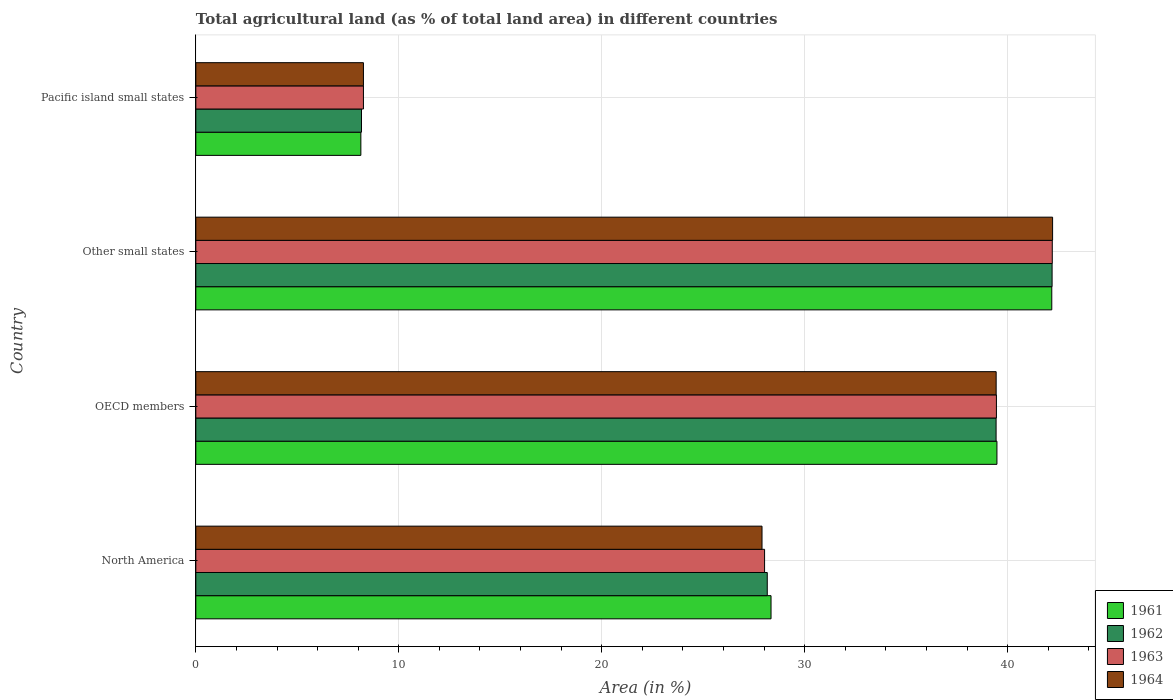Are the number of bars per tick equal to the number of legend labels?
Ensure brevity in your answer.  Yes. Are the number of bars on each tick of the Y-axis equal?
Give a very brief answer. Yes. How many bars are there on the 1st tick from the top?
Your answer should be compact. 4. How many bars are there on the 4th tick from the bottom?
Ensure brevity in your answer.  4. What is the percentage of agricultural land in 1961 in Other small states?
Provide a succinct answer. 42.18. Across all countries, what is the maximum percentage of agricultural land in 1962?
Keep it short and to the point. 42.19. Across all countries, what is the minimum percentage of agricultural land in 1961?
Your response must be concise. 8.13. In which country was the percentage of agricultural land in 1964 maximum?
Provide a short and direct response. Other small states. In which country was the percentage of agricultural land in 1961 minimum?
Ensure brevity in your answer.  Pacific island small states. What is the total percentage of agricultural land in 1963 in the graph?
Give a very brief answer. 117.93. What is the difference between the percentage of agricultural land in 1962 in OECD members and that in Pacific island small states?
Provide a short and direct response. 31.27. What is the difference between the percentage of agricultural land in 1962 in OECD members and the percentage of agricultural land in 1961 in Other small states?
Give a very brief answer. -2.74. What is the average percentage of agricultural land in 1962 per country?
Ensure brevity in your answer.  29.49. What is the difference between the percentage of agricultural land in 1962 and percentage of agricultural land in 1961 in OECD members?
Provide a succinct answer. -0.04. What is the ratio of the percentage of agricultural land in 1961 in North America to that in Pacific island small states?
Keep it short and to the point. 3.49. What is the difference between the highest and the second highest percentage of agricultural land in 1961?
Your answer should be compact. 2.7. What is the difference between the highest and the lowest percentage of agricultural land in 1961?
Give a very brief answer. 34.04. Is the sum of the percentage of agricultural land in 1963 in Other small states and Pacific island small states greater than the maximum percentage of agricultural land in 1962 across all countries?
Your answer should be compact. Yes. What does the 4th bar from the top in OECD members represents?
Provide a short and direct response. 1961. What does the 1st bar from the bottom in North America represents?
Offer a very short reply. 1961. Is it the case that in every country, the sum of the percentage of agricultural land in 1961 and percentage of agricultural land in 1962 is greater than the percentage of agricultural land in 1963?
Make the answer very short. Yes. Are all the bars in the graph horizontal?
Offer a very short reply. Yes. How many countries are there in the graph?
Your answer should be compact. 4. What is the difference between two consecutive major ticks on the X-axis?
Your answer should be compact. 10. Are the values on the major ticks of X-axis written in scientific E-notation?
Provide a succinct answer. No. Does the graph contain grids?
Provide a succinct answer. Yes. What is the title of the graph?
Make the answer very short. Total agricultural land (as % of total land area) in different countries. What is the label or title of the X-axis?
Offer a very short reply. Area (in %). What is the label or title of the Y-axis?
Offer a very short reply. Country. What is the Area (in %) in 1961 in North America?
Your answer should be compact. 28.34. What is the Area (in %) in 1962 in North America?
Offer a terse response. 28.16. What is the Area (in %) in 1963 in North America?
Ensure brevity in your answer.  28.02. What is the Area (in %) in 1964 in North America?
Your answer should be compact. 27.9. What is the Area (in %) of 1961 in OECD members?
Offer a very short reply. 39.47. What is the Area (in %) of 1962 in OECD members?
Your response must be concise. 39.43. What is the Area (in %) in 1963 in OECD members?
Your answer should be very brief. 39.45. What is the Area (in %) of 1964 in OECD members?
Offer a terse response. 39.44. What is the Area (in %) in 1961 in Other small states?
Make the answer very short. 42.18. What is the Area (in %) in 1962 in Other small states?
Provide a short and direct response. 42.19. What is the Area (in %) in 1963 in Other small states?
Provide a short and direct response. 42.2. What is the Area (in %) in 1964 in Other small states?
Your answer should be very brief. 42.22. What is the Area (in %) of 1961 in Pacific island small states?
Your response must be concise. 8.13. What is the Area (in %) of 1962 in Pacific island small states?
Your response must be concise. 8.16. What is the Area (in %) in 1963 in Pacific island small states?
Give a very brief answer. 8.26. What is the Area (in %) of 1964 in Pacific island small states?
Provide a short and direct response. 8.26. Across all countries, what is the maximum Area (in %) of 1961?
Your response must be concise. 42.18. Across all countries, what is the maximum Area (in %) of 1962?
Your answer should be very brief. 42.19. Across all countries, what is the maximum Area (in %) in 1963?
Offer a terse response. 42.2. Across all countries, what is the maximum Area (in %) in 1964?
Ensure brevity in your answer.  42.22. Across all countries, what is the minimum Area (in %) in 1961?
Provide a short and direct response. 8.13. Across all countries, what is the minimum Area (in %) in 1962?
Your answer should be compact. 8.16. Across all countries, what is the minimum Area (in %) in 1963?
Provide a succinct answer. 8.26. Across all countries, what is the minimum Area (in %) in 1964?
Provide a short and direct response. 8.26. What is the total Area (in %) of 1961 in the graph?
Offer a terse response. 118.13. What is the total Area (in %) in 1962 in the graph?
Make the answer very short. 117.95. What is the total Area (in %) of 1963 in the graph?
Make the answer very short. 117.93. What is the total Area (in %) in 1964 in the graph?
Give a very brief answer. 117.81. What is the difference between the Area (in %) in 1961 in North America and that in OECD members?
Keep it short and to the point. -11.13. What is the difference between the Area (in %) of 1962 in North America and that in OECD members?
Give a very brief answer. -11.28. What is the difference between the Area (in %) of 1963 in North America and that in OECD members?
Offer a terse response. -11.42. What is the difference between the Area (in %) in 1964 in North America and that in OECD members?
Your answer should be very brief. -11.54. What is the difference between the Area (in %) in 1961 in North America and that in Other small states?
Make the answer very short. -13.83. What is the difference between the Area (in %) of 1962 in North America and that in Other small states?
Provide a succinct answer. -14.03. What is the difference between the Area (in %) of 1963 in North America and that in Other small states?
Give a very brief answer. -14.18. What is the difference between the Area (in %) in 1964 in North America and that in Other small states?
Your answer should be compact. -14.32. What is the difference between the Area (in %) of 1961 in North America and that in Pacific island small states?
Your answer should be very brief. 20.21. What is the difference between the Area (in %) of 1962 in North America and that in Pacific island small states?
Give a very brief answer. 19.99. What is the difference between the Area (in %) of 1963 in North America and that in Pacific island small states?
Make the answer very short. 19.77. What is the difference between the Area (in %) of 1964 in North America and that in Pacific island small states?
Offer a very short reply. 19.64. What is the difference between the Area (in %) of 1961 in OECD members and that in Other small states?
Make the answer very short. -2.7. What is the difference between the Area (in %) of 1962 in OECD members and that in Other small states?
Your response must be concise. -2.76. What is the difference between the Area (in %) in 1963 in OECD members and that in Other small states?
Ensure brevity in your answer.  -2.75. What is the difference between the Area (in %) of 1964 in OECD members and that in Other small states?
Provide a short and direct response. -2.78. What is the difference between the Area (in %) in 1961 in OECD members and that in Pacific island small states?
Ensure brevity in your answer.  31.34. What is the difference between the Area (in %) of 1962 in OECD members and that in Pacific island small states?
Make the answer very short. 31.27. What is the difference between the Area (in %) in 1963 in OECD members and that in Pacific island small states?
Your answer should be compact. 31.19. What is the difference between the Area (in %) of 1964 in OECD members and that in Pacific island small states?
Offer a very short reply. 31.18. What is the difference between the Area (in %) in 1961 in Other small states and that in Pacific island small states?
Offer a very short reply. 34.04. What is the difference between the Area (in %) of 1962 in Other small states and that in Pacific island small states?
Your response must be concise. 34.03. What is the difference between the Area (in %) of 1963 in Other small states and that in Pacific island small states?
Your answer should be compact. 33.94. What is the difference between the Area (in %) in 1964 in Other small states and that in Pacific island small states?
Provide a succinct answer. 33.96. What is the difference between the Area (in %) in 1961 in North America and the Area (in %) in 1962 in OECD members?
Offer a very short reply. -11.09. What is the difference between the Area (in %) in 1961 in North America and the Area (in %) in 1963 in OECD members?
Offer a very short reply. -11.11. What is the difference between the Area (in %) in 1961 in North America and the Area (in %) in 1964 in OECD members?
Your answer should be very brief. -11.09. What is the difference between the Area (in %) in 1962 in North America and the Area (in %) in 1963 in OECD members?
Your answer should be very brief. -11.29. What is the difference between the Area (in %) of 1962 in North America and the Area (in %) of 1964 in OECD members?
Make the answer very short. -11.28. What is the difference between the Area (in %) of 1963 in North America and the Area (in %) of 1964 in OECD members?
Your answer should be very brief. -11.41. What is the difference between the Area (in %) in 1961 in North America and the Area (in %) in 1962 in Other small states?
Your answer should be compact. -13.85. What is the difference between the Area (in %) of 1961 in North America and the Area (in %) of 1963 in Other small states?
Keep it short and to the point. -13.86. What is the difference between the Area (in %) of 1961 in North America and the Area (in %) of 1964 in Other small states?
Provide a succinct answer. -13.87. What is the difference between the Area (in %) of 1962 in North America and the Area (in %) of 1963 in Other small states?
Your answer should be very brief. -14.04. What is the difference between the Area (in %) in 1962 in North America and the Area (in %) in 1964 in Other small states?
Provide a succinct answer. -14.06. What is the difference between the Area (in %) of 1963 in North America and the Area (in %) of 1964 in Other small states?
Offer a terse response. -14.19. What is the difference between the Area (in %) in 1961 in North America and the Area (in %) in 1962 in Pacific island small states?
Make the answer very short. 20.18. What is the difference between the Area (in %) of 1961 in North America and the Area (in %) of 1963 in Pacific island small states?
Provide a succinct answer. 20.08. What is the difference between the Area (in %) of 1961 in North America and the Area (in %) of 1964 in Pacific island small states?
Make the answer very short. 20.08. What is the difference between the Area (in %) of 1962 in North America and the Area (in %) of 1963 in Pacific island small states?
Make the answer very short. 19.9. What is the difference between the Area (in %) of 1962 in North America and the Area (in %) of 1964 in Pacific island small states?
Keep it short and to the point. 19.9. What is the difference between the Area (in %) in 1963 in North America and the Area (in %) in 1964 in Pacific island small states?
Your answer should be very brief. 19.77. What is the difference between the Area (in %) of 1961 in OECD members and the Area (in %) of 1962 in Other small states?
Offer a very short reply. -2.72. What is the difference between the Area (in %) in 1961 in OECD members and the Area (in %) in 1963 in Other small states?
Offer a very short reply. -2.73. What is the difference between the Area (in %) of 1961 in OECD members and the Area (in %) of 1964 in Other small states?
Your answer should be compact. -2.74. What is the difference between the Area (in %) of 1962 in OECD members and the Area (in %) of 1963 in Other small states?
Offer a very short reply. -2.77. What is the difference between the Area (in %) of 1962 in OECD members and the Area (in %) of 1964 in Other small states?
Your response must be concise. -2.78. What is the difference between the Area (in %) of 1963 in OECD members and the Area (in %) of 1964 in Other small states?
Ensure brevity in your answer.  -2.77. What is the difference between the Area (in %) of 1961 in OECD members and the Area (in %) of 1962 in Pacific island small states?
Keep it short and to the point. 31.31. What is the difference between the Area (in %) of 1961 in OECD members and the Area (in %) of 1963 in Pacific island small states?
Ensure brevity in your answer.  31.22. What is the difference between the Area (in %) in 1961 in OECD members and the Area (in %) in 1964 in Pacific island small states?
Make the answer very short. 31.22. What is the difference between the Area (in %) in 1962 in OECD members and the Area (in %) in 1963 in Pacific island small states?
Your response must be concise. 31.17. What is the difference between the Area (in %) in 1962 in OECD members and the Area (in %) in 1964 in Pacific island small states?
Provide a short and direct response. 31.17. What is the difference between the Area (in %) in 1963 in OECD members and the Area (in %) in 1964 in Pacific island small states?
Make the answer very short. 31.19. What is the difference between the Area (in %) of 1961 in Other small states and the Area (in %) of 1962 in Pacific island small states?
Give a very brief answer. 34.01. What is the difference between the Area (in %) of 1961 in Other small states and the Area (in %) of 1963 in Pacific island small states?
Keep it short and to the point. 33.92. What is the difference between the Area (in %) in 1961 in Other small states and the Area (in %) in 1964 in Pacific island small states?
Your answer should be very brief. 33.92. What is the difference between the Area (in %) of 1962 in Other small states and the Area (in %) of 1963 in Pacific island small states?
Offer a very short reply. 33.93. What is the difference between the Area (in %) in 1962 in Other small states and the Area (in %) in 1964 in Pacific island small states?
Make the answer very short. 33.93. What is the difference between the Area (in %) in 1963 in Other small states and the Area (in %) in 1964 in Pacific island small states?
Provide a succinct answer. 33.94. What is the average Area (in %) in 1961 per country?
Offer a terse response. 29.53. What is the average Area (in %) of 1962 per country?
Your answer should be very brief. 29.49. What is the average Area (in %) in 1963 per country?
Provide a succinct answer. 29.48. What is the average Area (in %) in 1964 per country?
Your answer should be compact. 29.45. What is the difference between the Area (in %) of 1961 and Area (in %) of 1962 in North America?
Keep it short and to the point. 0.19. What is the difference between the Area (in %) in 1961 and Area (in %) in 1963 in North America?
Ensure brevity in your answer.  0.32. What is the difference between the Area (in %) in 1961 and Area (in %) in 1964 in North America?
Provide a succinct answer. 0.44. What is the difference between the Area (in %) in 1962 and Area (in %) in 1963 in North America?
Your response must be concise. 0.13. What is the difference between the Area (in %) of 1962 and Area (in %) of 1964 in North America?
Your response must be concise. 0.26. What is the difference between the Area (in %) of 1963 and Area (in %) of 1964 in North America?
Offer a terse response. 0.13. What is the difference between the Area (in %) in 1961 and Area (in %) in 1962 in OECD members?
Your answer should be compact. 0.04. What is the difference between the Area (in %) in 1961 and Area (in %) in 1963 in OECD members?
Provide a short and direct response. 0.03. What is the difference between the Area (in %) of 1961 and Area (in %) of 1964 in OECD members?
Provide a succinct answer. 0.04. What is the difference between the Area (in %) of 1962 and Area (in %) of 1963 in OECD members?
Make the answer very short. -0.02. What is the difference between the Area (in %) of 1962 and Area (in %) of 1964 in OECD members?
Keep it short and to the point. -0. What is the difference between the Area (in %) in 1963 and Area (in %) in 1964 in OECD members?
Keep it short and to the point. 0.01. What is the difference between the Area (in %) of 1961 and Area (in %) of 1962 in Other small states?
Ensure brevity in your answer.  -0.02. What is the difference between the Area (in %) in 1961 and Area (in %) in 1963 in Other small states?
Keep it short and to the point. -0.02. What is the difference between the Area (in %) in 1961 and Area (in %) in 1964 in Other small states?
Ensure brevity in your answer.  -0.04. What is the difference between the Area (in %) of 1962 and Area (in %) of 1963 in Other small states?
Your response must be concise. -0.01. What is the difference between the Area (in %) of 1962 and Area (in %) of 1964 in Other small states?
Make the answer very short. -0.02. What is the difference between the Area (in %) of 1963 and Area (in %) of 1964 in Other small states?
Make the answer very short. -0.02. What is the difference between the Area (in %) in 1961 and Area (in %) in 1962 in Pacific island small states?
Your answer should be compact. -0.03. What is the difference between the Area (in %) in 1961 and Area (in %) in 1963 in Pacific island small states?
Provide a succinct answer. -0.13. What is the difference between the Area (in %) of 1961 and Area (in %) of 1964 in Pacific island small states?
Your answer should be very brief. -0.13. What is the difference between the Area (in %) of 1962 and Area (in %) of 1963 in Pacific island small states?
Offer a terse response. -0.1. What is the difference between the Area (in %) of 1962 and Area (in %) of 1964 in Pacific island small states?
Provide a short and direct response. -0.1. What is the ratio of the Area (in %) in 1961 in North America to that in OECD members?
Offer a terse response. 0.72. What is the ratio of the Area (in %) of 1962 in North America to that in OECD members?
Your response must be concise. 0.71. What is the ratio of the Area (in %) of 1963 in North America to that in OECD members?
Your response must be concise. 0.71. What is the ratio of the Area (in %) of 1964 in North America to that in OECD members?
Offer a terse response. 0.71. What is the ratio of the Area (in %) in 1961 in North America to that in Other small states?
Offer a terse response. 0.67. What is the ratio of the Area (in %) in 1962 in North America to that in Other small states?
Your answer should be compact. 0.67. What is the ratio of the Area (in %) of 1963 in North America to that in Other small states?
Offer a terse response. 0.66. What is the ratio of the Area (in %) of 1964 in North America to that in Other small states?
Your answer should be very brief. 0.66. What is the ratio of the Area (in %) of 1961 in North America to that in Pacific island small states?
Ensure brevity in your answer.  3.49. What is the ratio of the Area (in %) of 1962 in North America to that in Pacific island small states?
Offer a very short reply. 3.45. What is the ratio of the Area (in %) of 1963 in North America to that in Pacific island small states?
Make the answer very short. 3.39. What is the ratio of the Area (in %) in 1964 in North America to that in Pacific island small states?
Offer a terse response. 3.38. What is the ratio of the Area (in %) in 1961 in OECD members to that in Other small states?
Offer a very short reply. 0.94. What is the ratio of the Area (in %) in 1962 in OECD members to that in Other small states?
Offer a very short reply. 0.93. What is the ratio of the Area (in %) in 1963 in OECD members to that in Other small states?
Offer a very short reply. 0.93. What is the ratio of the Area (in %) of 1964 in OECD members to that in Other small states?
Ensure brevity in your answer.  0.93. What is the ratio of the Area (in %) of 1961 in OECD members to that in Pacific island small states?
Provide a short and direct response. 4.85. What is the ratio of the Area (in %) of 1962 in OECD members to that in Pacific island small states?
Offer a terse response. 4.83. What is the ratio of the Area (in %) of 1963 in OECD members to that in Pacific island small states?
Provide a short and direct response. 4.78. What is the ratio of the Area (in %) of 1964 in OECD members to that in Pacific island small states?
Your answer should be very brief. 4.77. What is the ratio of the Area (in %) in 1961 in Other small states to that in Pacific island small states?
Give a very brief answer. 5.19. What is the ratio of the Area (in %) of 1962 in Other small states to that in Pacific island small states?
Offer a terse response. 5.17. What is the ratio of the Area (in %) in 1963 in Other small states to that in Pacific island small states?
Give a very brief answer. 5.11. What is the ratio of the Area (in %) of 1964 in Other small states to that in Pacific island small states?
Offer a very short reply. 5.11. What is the difference between the highest and the second highest Area (in %) of 1961?
Ensure brevity in your answer.  2.7. What is the difference between the highest and the second highest Area (in %) in 1962?
Offer a terse response. 2.76. What is the difference between the highest and the second highest Area (in %) of 1963?
Ensure brevity in your answer.  2.75. What is the difference between the highest and the second highest Area (in %) in 1964?
Give a very brief answer. 2.78. What is the difference between the highest and the lowest Area (in %) of 1961?
Your answer should be compact. 34.04. What is the difference between the highest and the lowest Area (in %) of 1962?
Your response must be concise. 34.03. What is the difference between the highest and the lowest Area (in %) of 1963?
Give a very brief answer. 33.94. What is the difference between the highest and the lowest Area (in %) in 1964?
Offer a terse response. 33.96. 